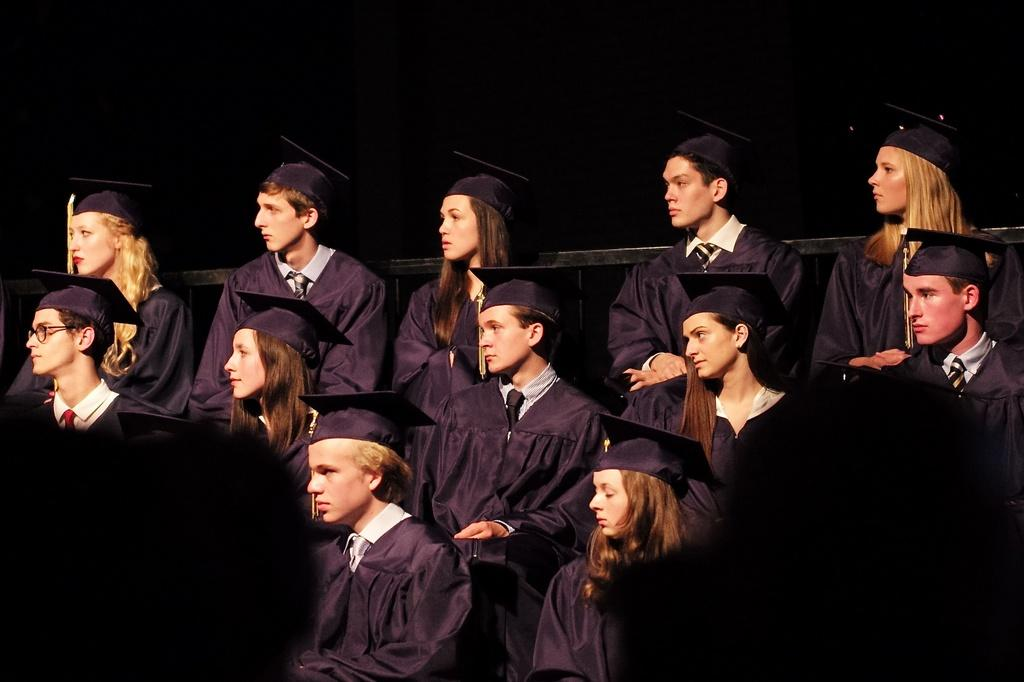How many people are in the image? There is a group of persons in the image. What are the persons doing in the image? The persons are sitting on benches. What time of day is depicted in the image? The provided facts do not mention the time of day, so it cannot be determined from the image. 